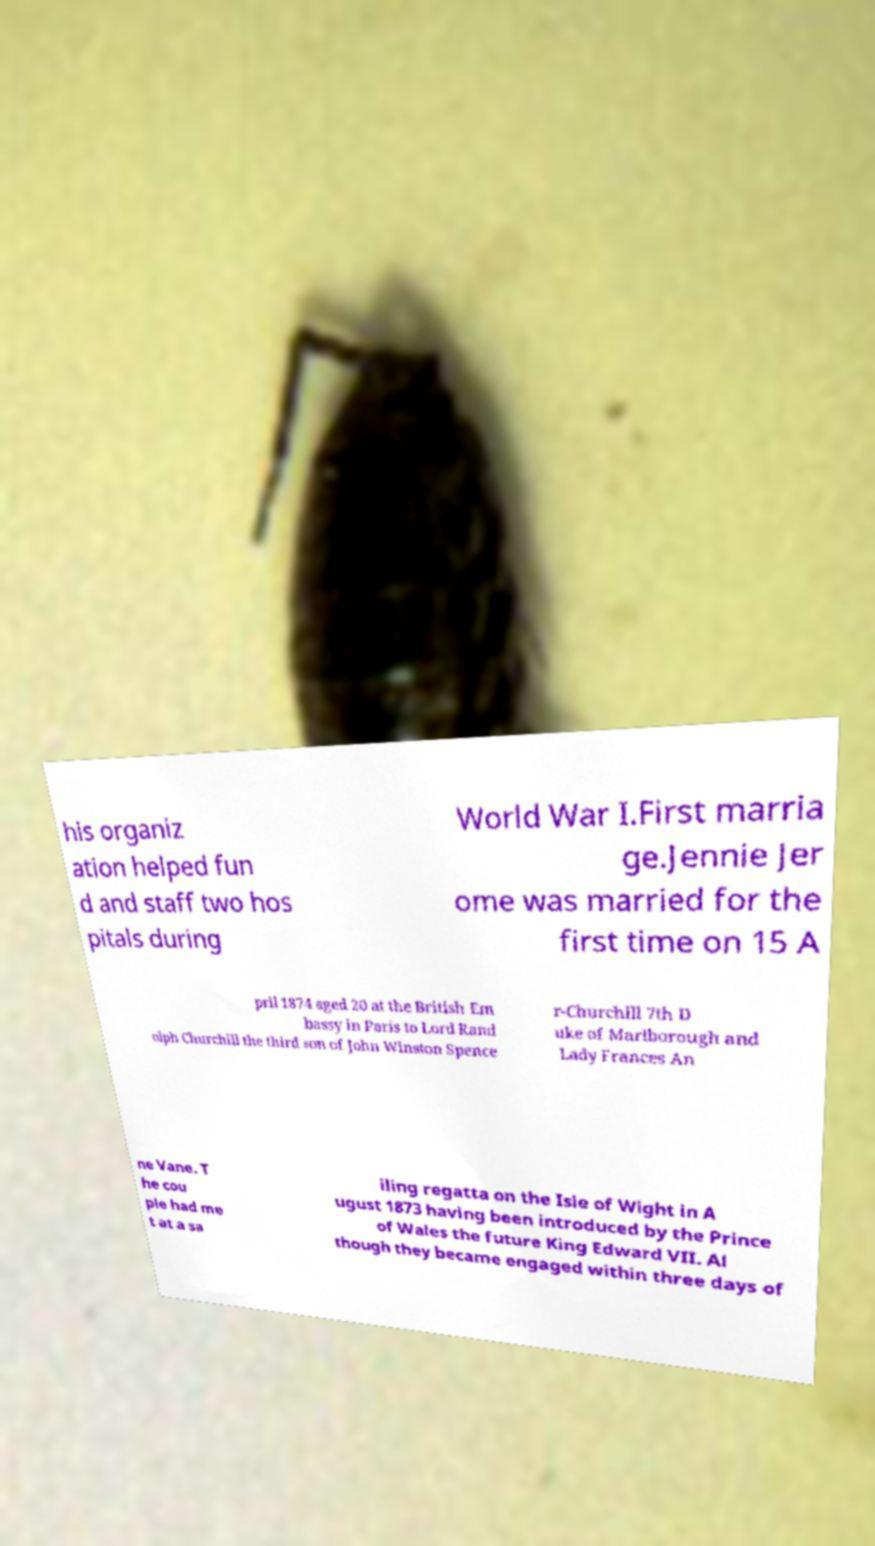For documentation purposes, I need the text within this image transcribed. Could you provide that? his organiz ation helped fun d and staff two hos pitals during World War I.First marria ge.Jennie Jer ome was married for the first time on 15 A pril 1874 aged 20 at the British Em bassy in Paris to Lord Rand olph Churchill the third son of John Winston Spence r-Churchill 7th D uke of Marlborough and Lady Frances An ne Vane. T he cou ple had me t at a sa iling regatta on the Isle of Wight in A ugust 1873 having been introduced by the Prince of Wales the future King Edward VII. Al though they became engaged within three days of 